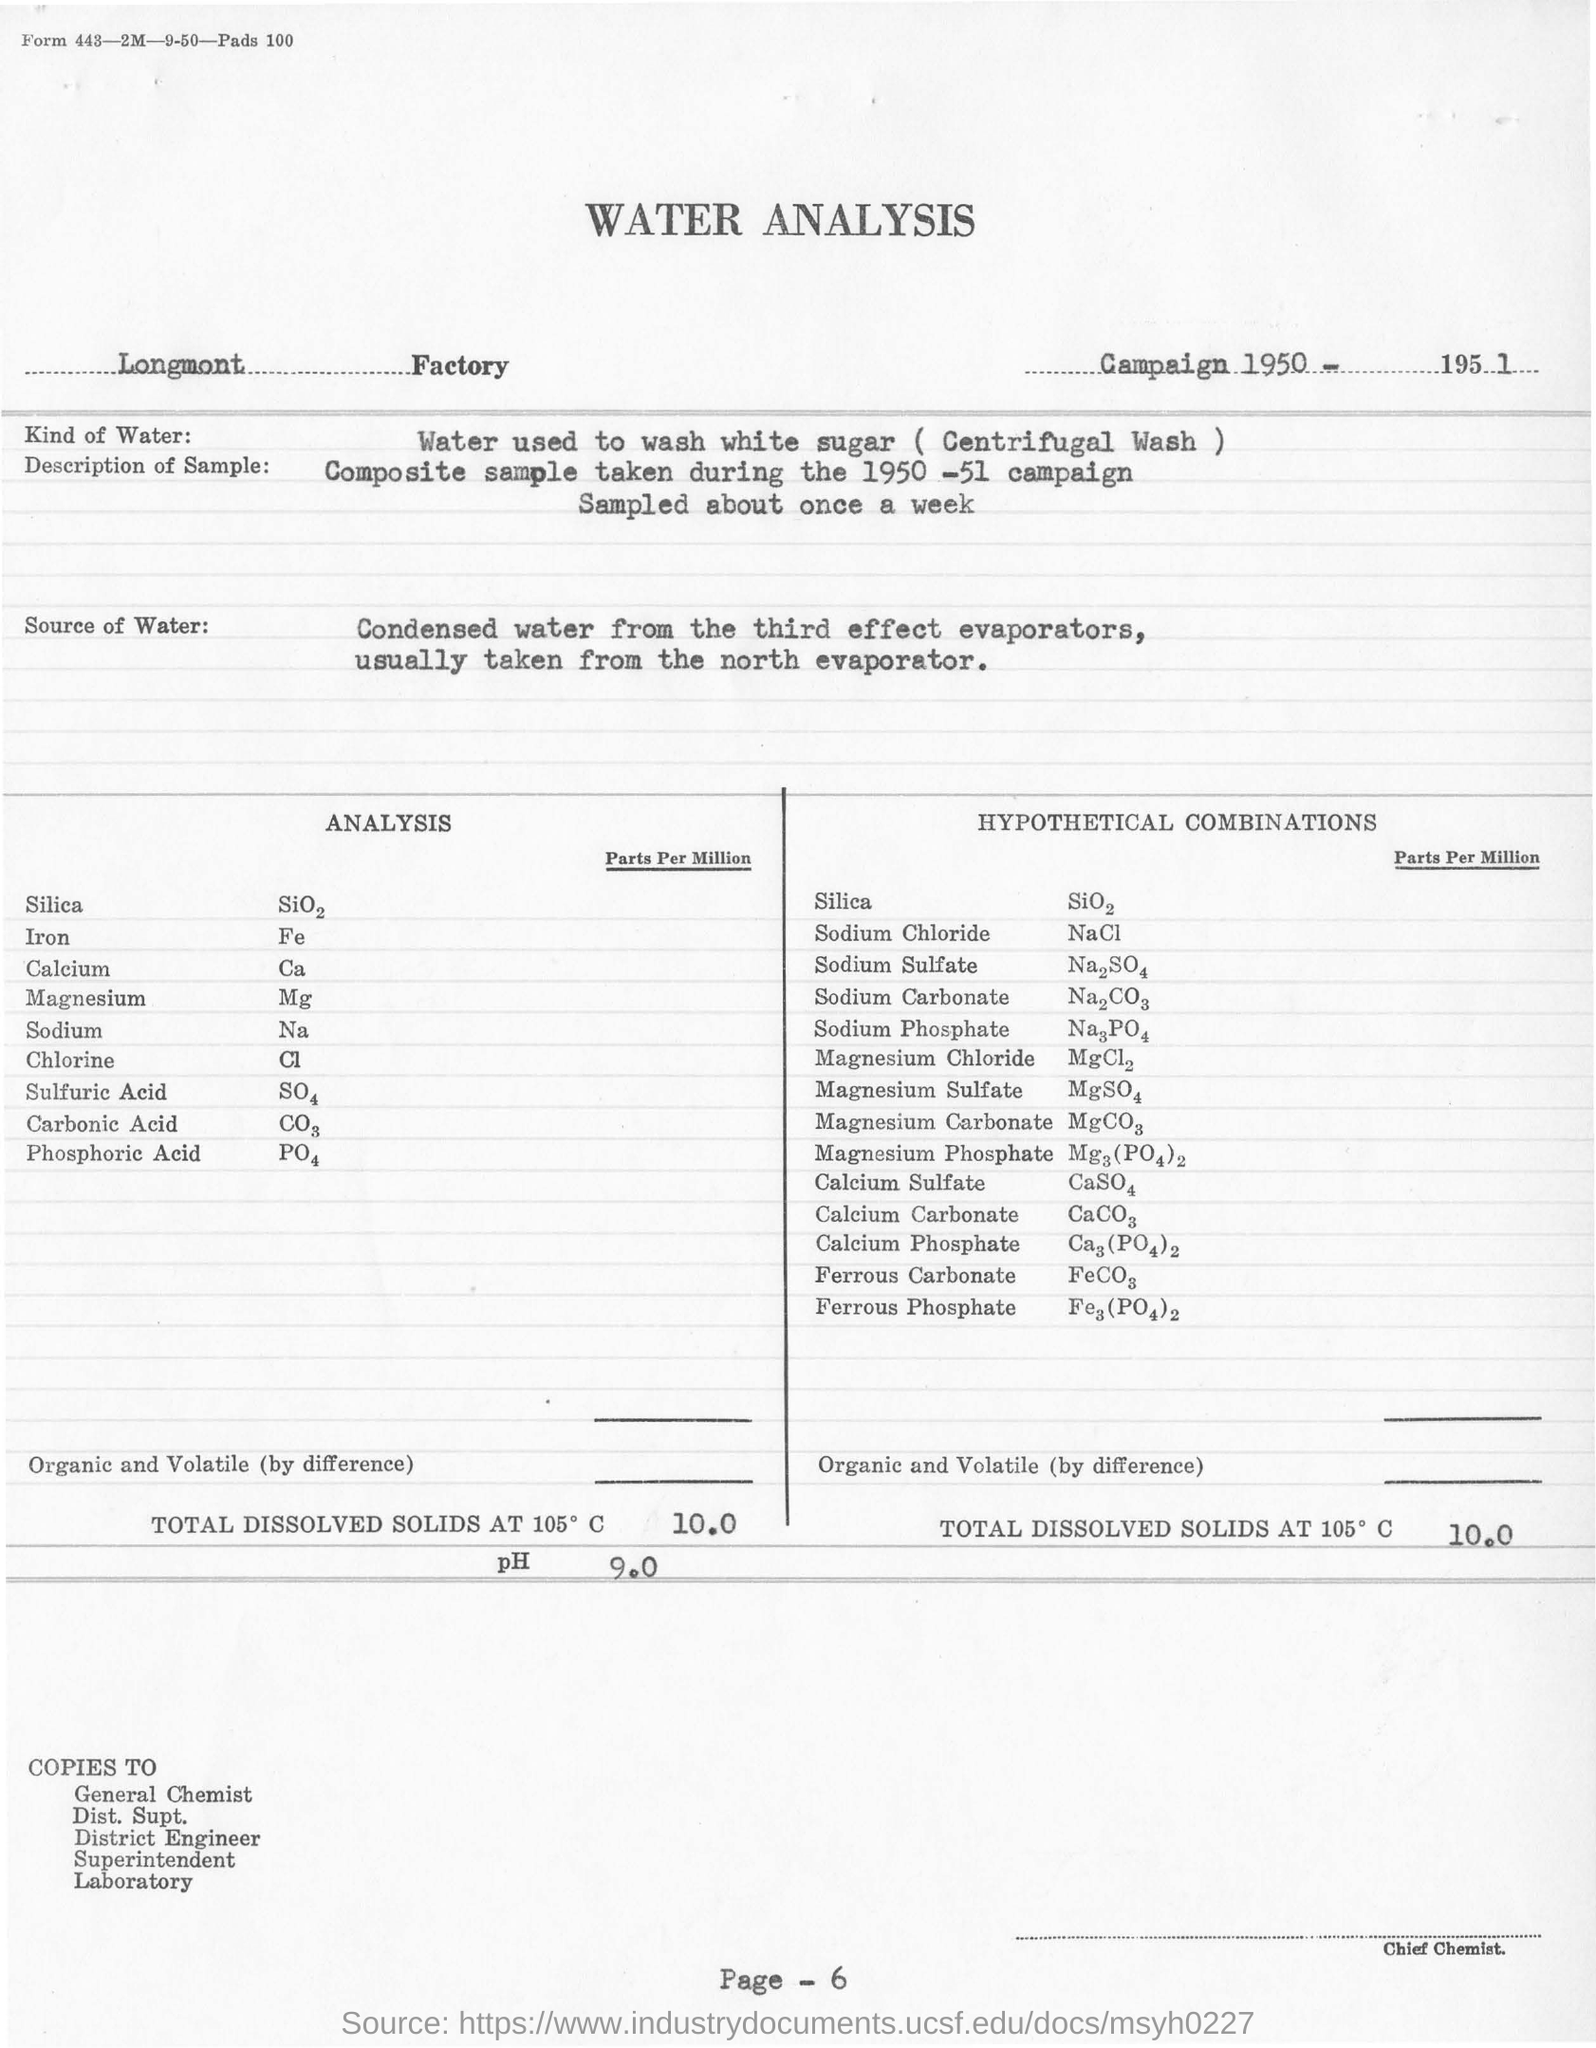Identify some key points in this picture. The name of the factory is Longmont. In the hypothetical combinations, the total dissolved solids present at 105 degrees C were 10.0... The copies of the water analysis will be sent to the general chemist named [insert name]. The pH value of the water sample taken from the Longmont factory is 9.0. At the Longmont factory, white sugar is washed by water. 